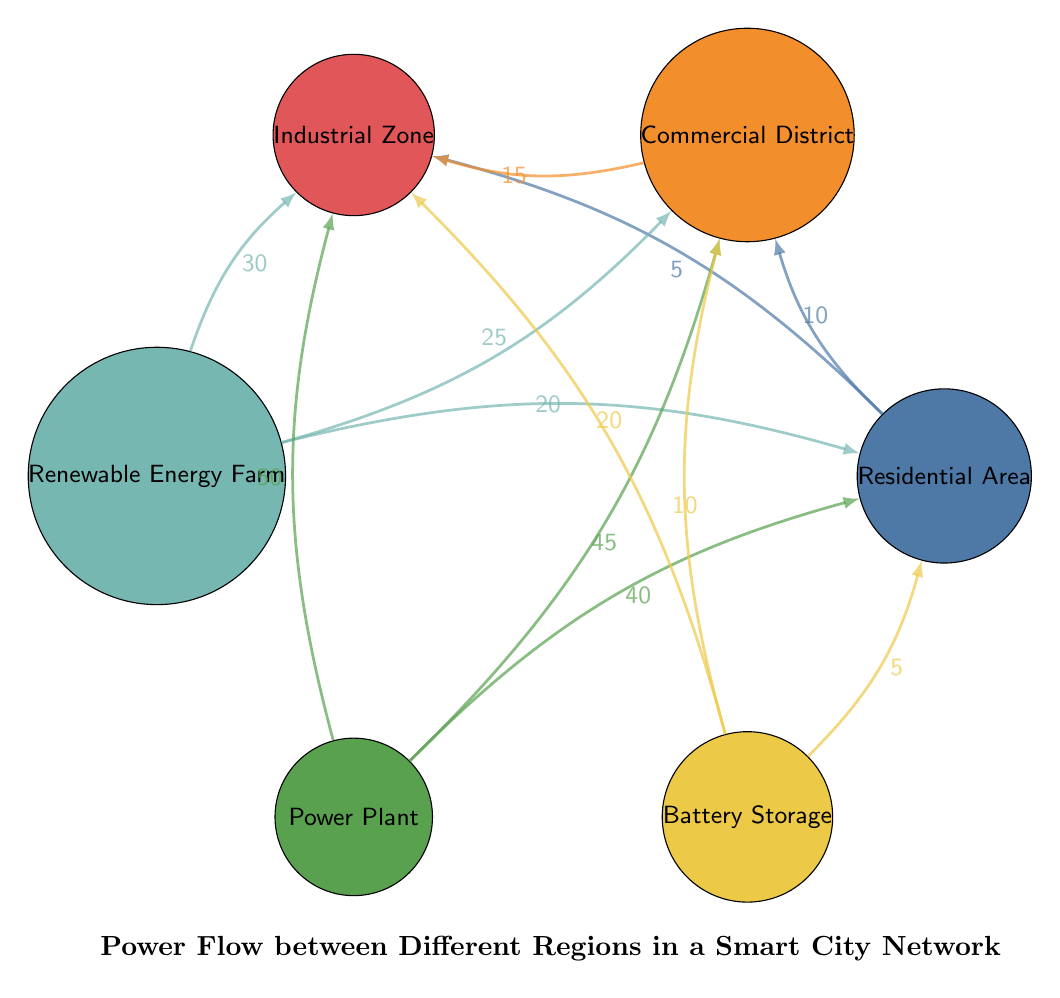What is the flow value from Residential Area to Commercial District? The flow from Residential Area to Commercial District is indicated as 10 in the diagram.
Answer: 10 What nodes are connected to the Industrial Zone? The Industrial Zone is connected to Residential Area, Commercial District, Renewable Energy Farm, Power Plant, and Battery Storage as shown in the links.
Answer: Residential Area, Commercial District, Renewable Energy Farm, Power Plant, Battery Storage Which region receives the most power from the Renewable Energy Farm? The Renewable Energy Farm sends power to Industrial Zone with a value of 30, which is the highest compared to other connections.
Answer: Industrial Zone What is the total flow value from the Power Plant? The Power Plant sends power to Residential Area (40), Commercial District (45), and Industrial Zone (50). Adding these values together gives a total flow of 135.
Answer: 135 What is the sum of power supplied to the Commercial District? The Commercial District receives power from Residential Area (10), Renewable Energy Farm (25), Power Plant (45), and Battery Storage (10). Summing these flows gives 10 + 25 + 45 + 10 = 90.
Answer: 90 How does the flow from Battery Storage compare with that from Renewable Energy Farm to Residential Area? Battery Storage sends 5 to Residential Area, while Renewable Energy Farm sends 20. Since 20 is greater than 5, Renewable Energy Farm supplies more power.
Answer: Renewable Energy Farm Which source contributes the least power to the Industrial Zone? The flow from Residential Area to Industrial Zone is 5, which is the lowest compared to other sources like Renewable Energy Farm (30), Power Plant (50), and Battery Storage (20).
Answer: Residential Area What is the total number of nodes in the diagram? The nodes include Residential Area, Commercial District, Industrial Zone, Renewable Energy Farm, Power Plant, and Battery Storage, totaling 6 nodes.
Answer: 6 Which node has the highest incoming flow value overall? The Power Plant has the highest incoming flow to Industrial Zone with a value of 50, which is the highest for any node in the diagram.
Answer: Industrial Zone 